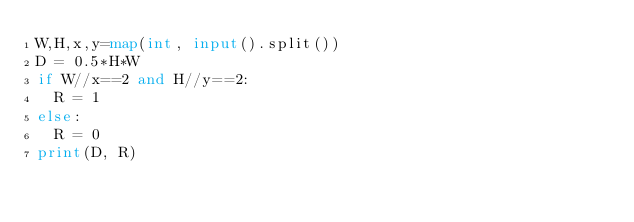<code> <loc_0><loc_0><loc_500><loc_500><_Python_>W,H,x,y=map(int, input().split())
D = 0.5*H*W
if W//x==2 and H//y==2:
  R = 1
else:
  R = 0
print(D, R)
</code> 